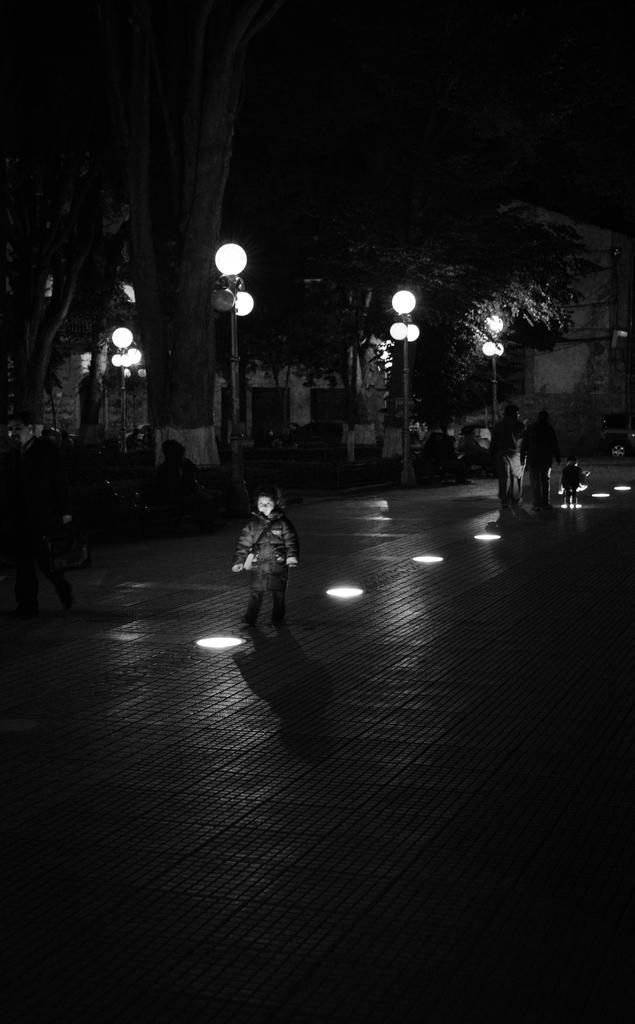How many people are in the image? There is a group of people in the image. What are the people in the image doing? The people are walking on a road. What can be seen in the background of the image? There are buildings, poles, lights, and trees in the background of the image. What is visible at the bottom of the image? There is a road visible at the bottom of the image. What color is the eye of the neck in the image? There is no neck or eye present in the image. 